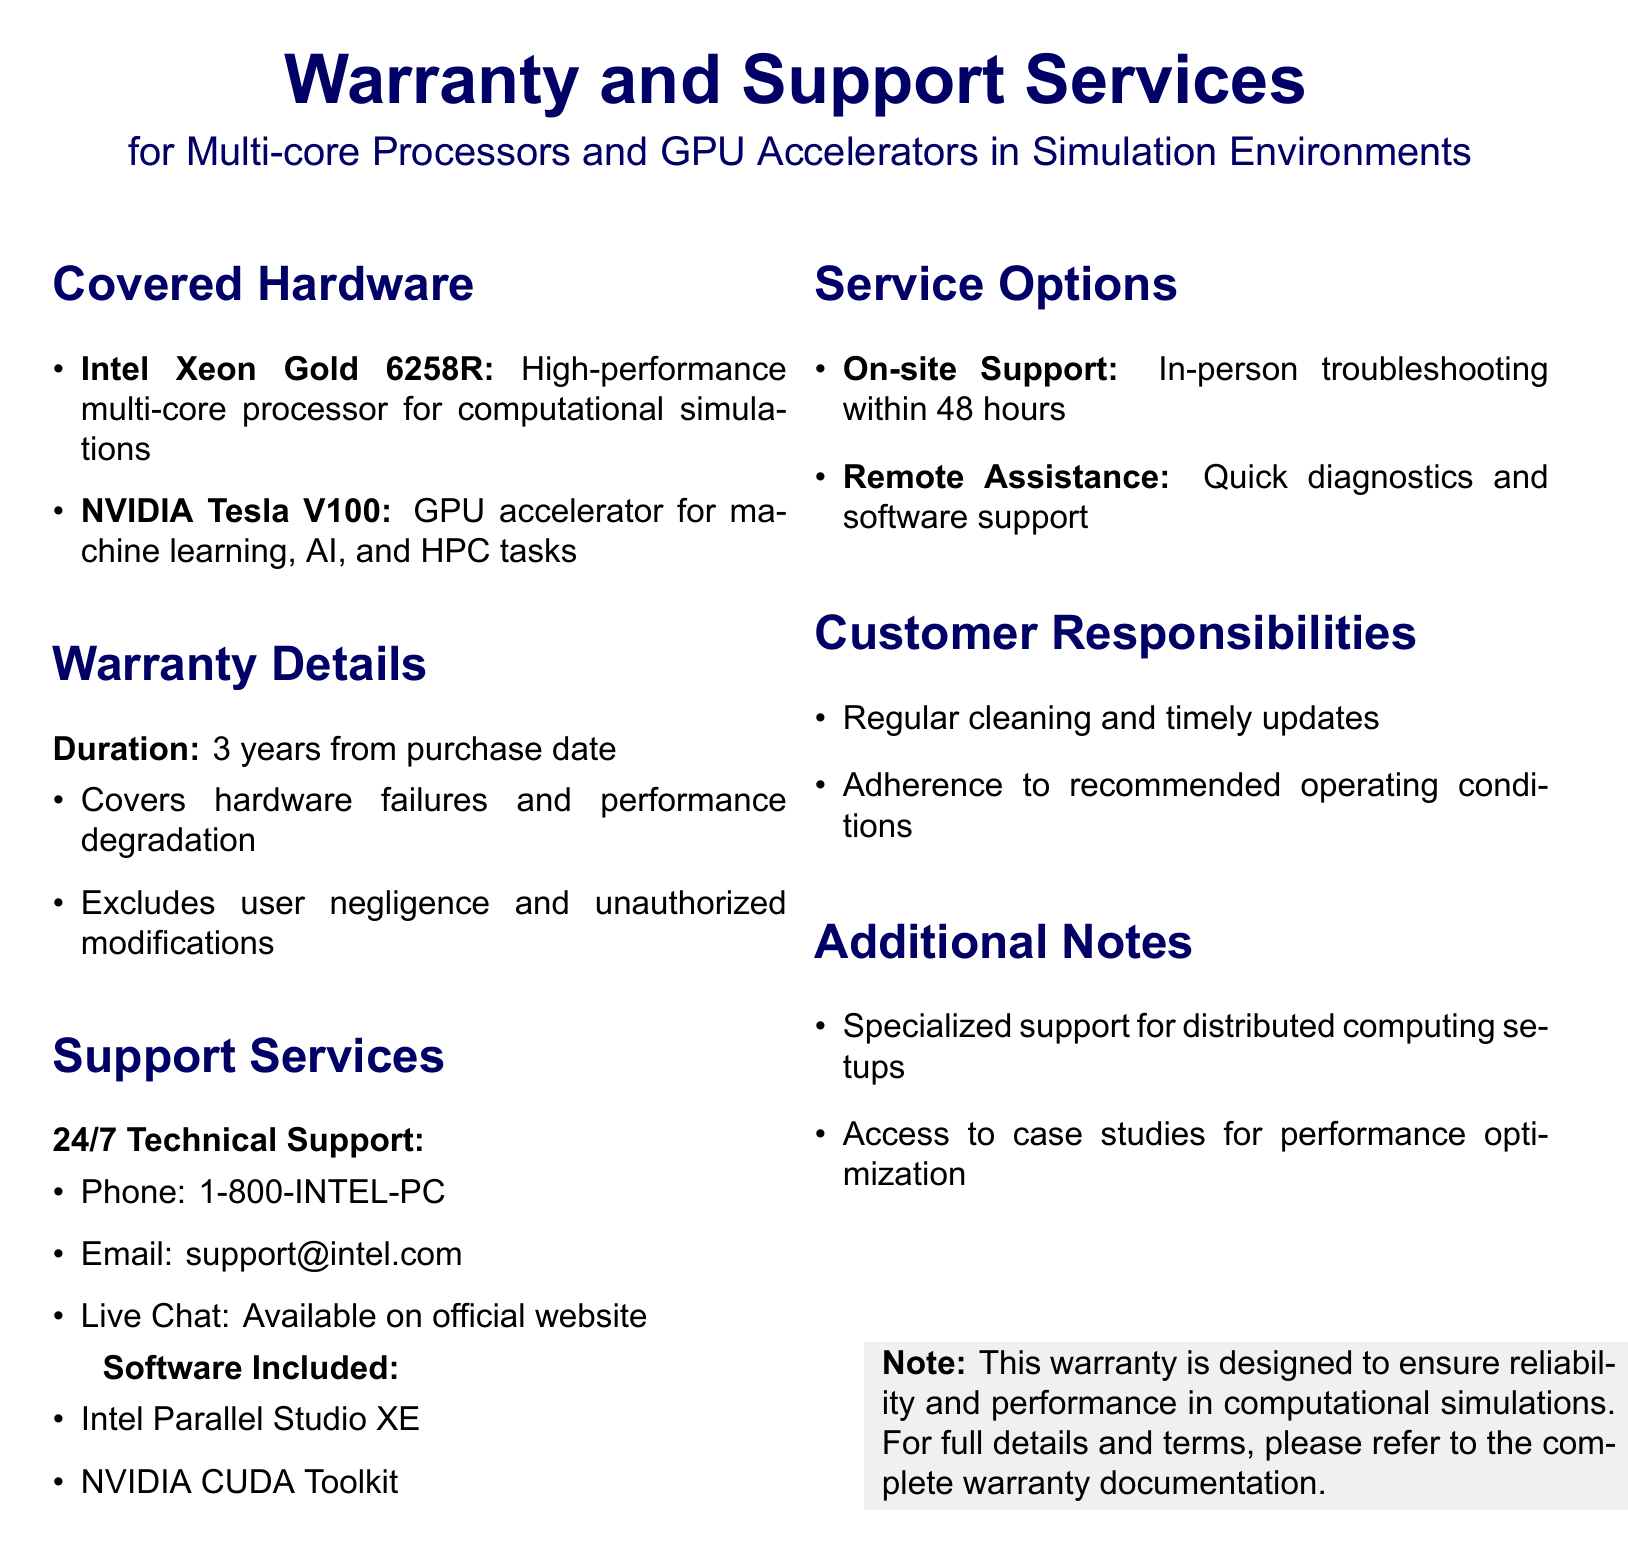what is the duration of the warranty? The warranty duration is clearly stated in the document as 3 years from the purchase date.
Answer: 3 years what types of hardware are covered? The document lists the specific processors covered, which include Intel Xeon Gold 6258R and NVIDIA Tesla V100.
Answer: Intel Xeon Gold 6258R, NVIDIA Tesla V100 what kind of support is available for customers? The document specifies that 24/7 technical support is provided through various methods, including phone and email.
Answer: 24/7 Technical Support what is the phone number for technical support? The document provides a specific contact number for technical support, which is listed in the support services section.
Answer: 1-800-INTEL-PC what is excluded from the warranty coverage? The document mentions that user negligence and unauthorized modifications are not covered under the warranty.
Answer: User negligence, unauthorized modifications how quickly can on-site support arrive? It is stated in the document that on-site support will provide assistance within a specific time frame.
Answer: Within 48 hours what customer responsibilities are mentioned? The document outlines certain responsibilities that customers must adhere to, including maintenance of the hardware.
Answer: Regular cleaning, timely updates, adherence to recommended operating conditions what software tools are included with the warranty? The document lists included software, specifically tools beneficial for simulations and parallel processing.
Answer: Intel Parallel Studio XE, NVIDIA CUDA Toolkit what service option provides quick diagnostics? The document mentions remote assistance as a service option for quick diagnostics and support.
Answer: Remote Assistance 